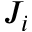<formula> <loc_0><loc_0><loc_500><loc_500>J _ { i }</formula> 